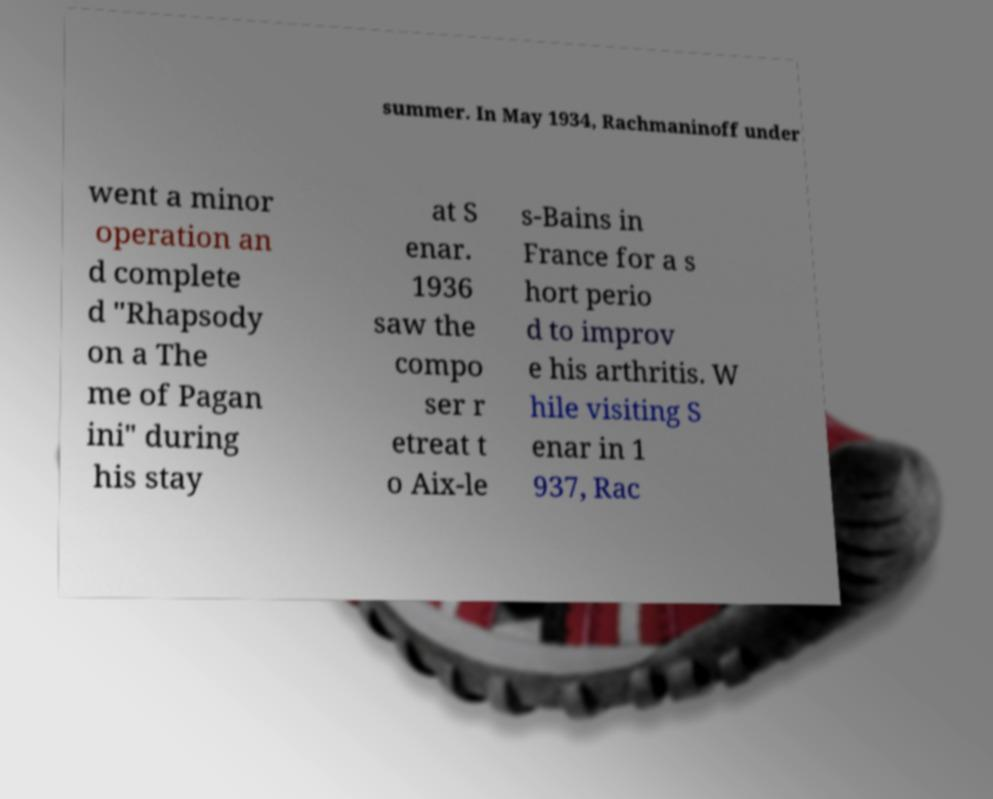I need the written content from this picture converted into text. Can you do that? summer. In May 1934, Rachmaninoff under went a minor operation an d complete d "Rhapsody on a The me of Pagan ini" during his stay at S enar. 1936 saw the compo ser r etreat t o Aix-le s-Bains in France for a s hort perio d to improv e his arthritis. W hile visiting S enar in 1 937, Rac 